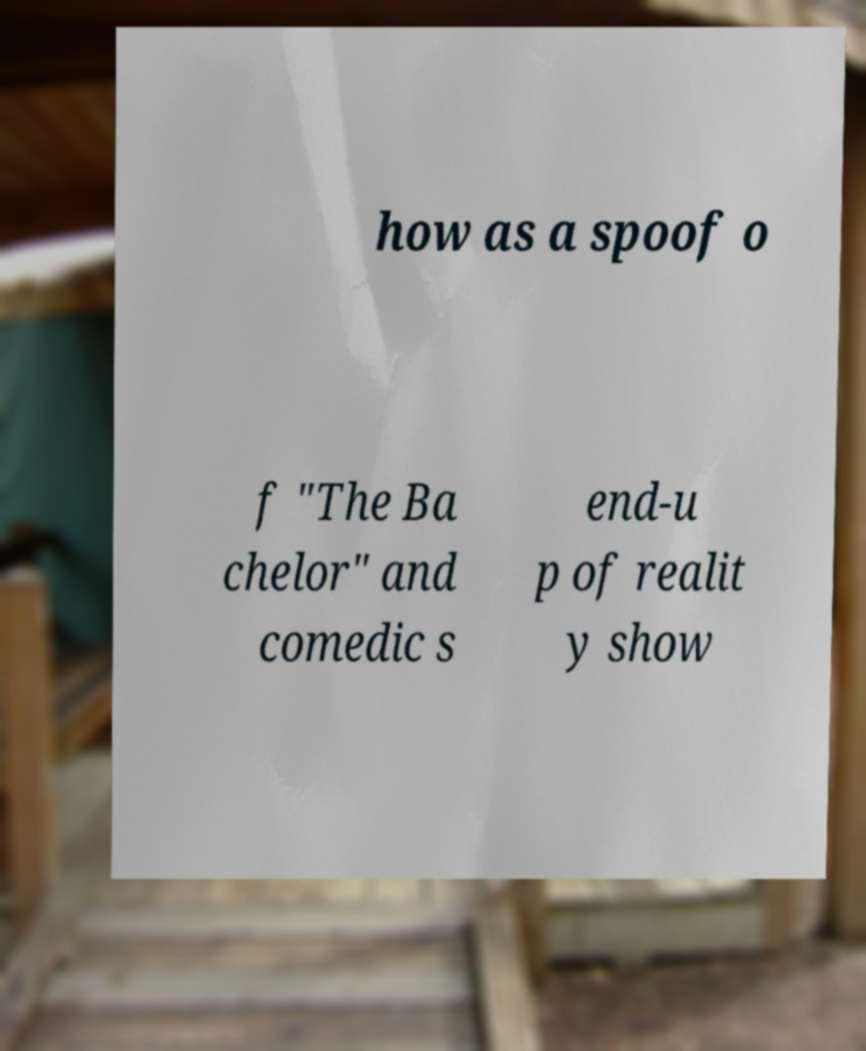Please identify and transcribe the text found in this image. how as a spoof o f "The Ba chelor" and comedic s end-u p of realit y show 